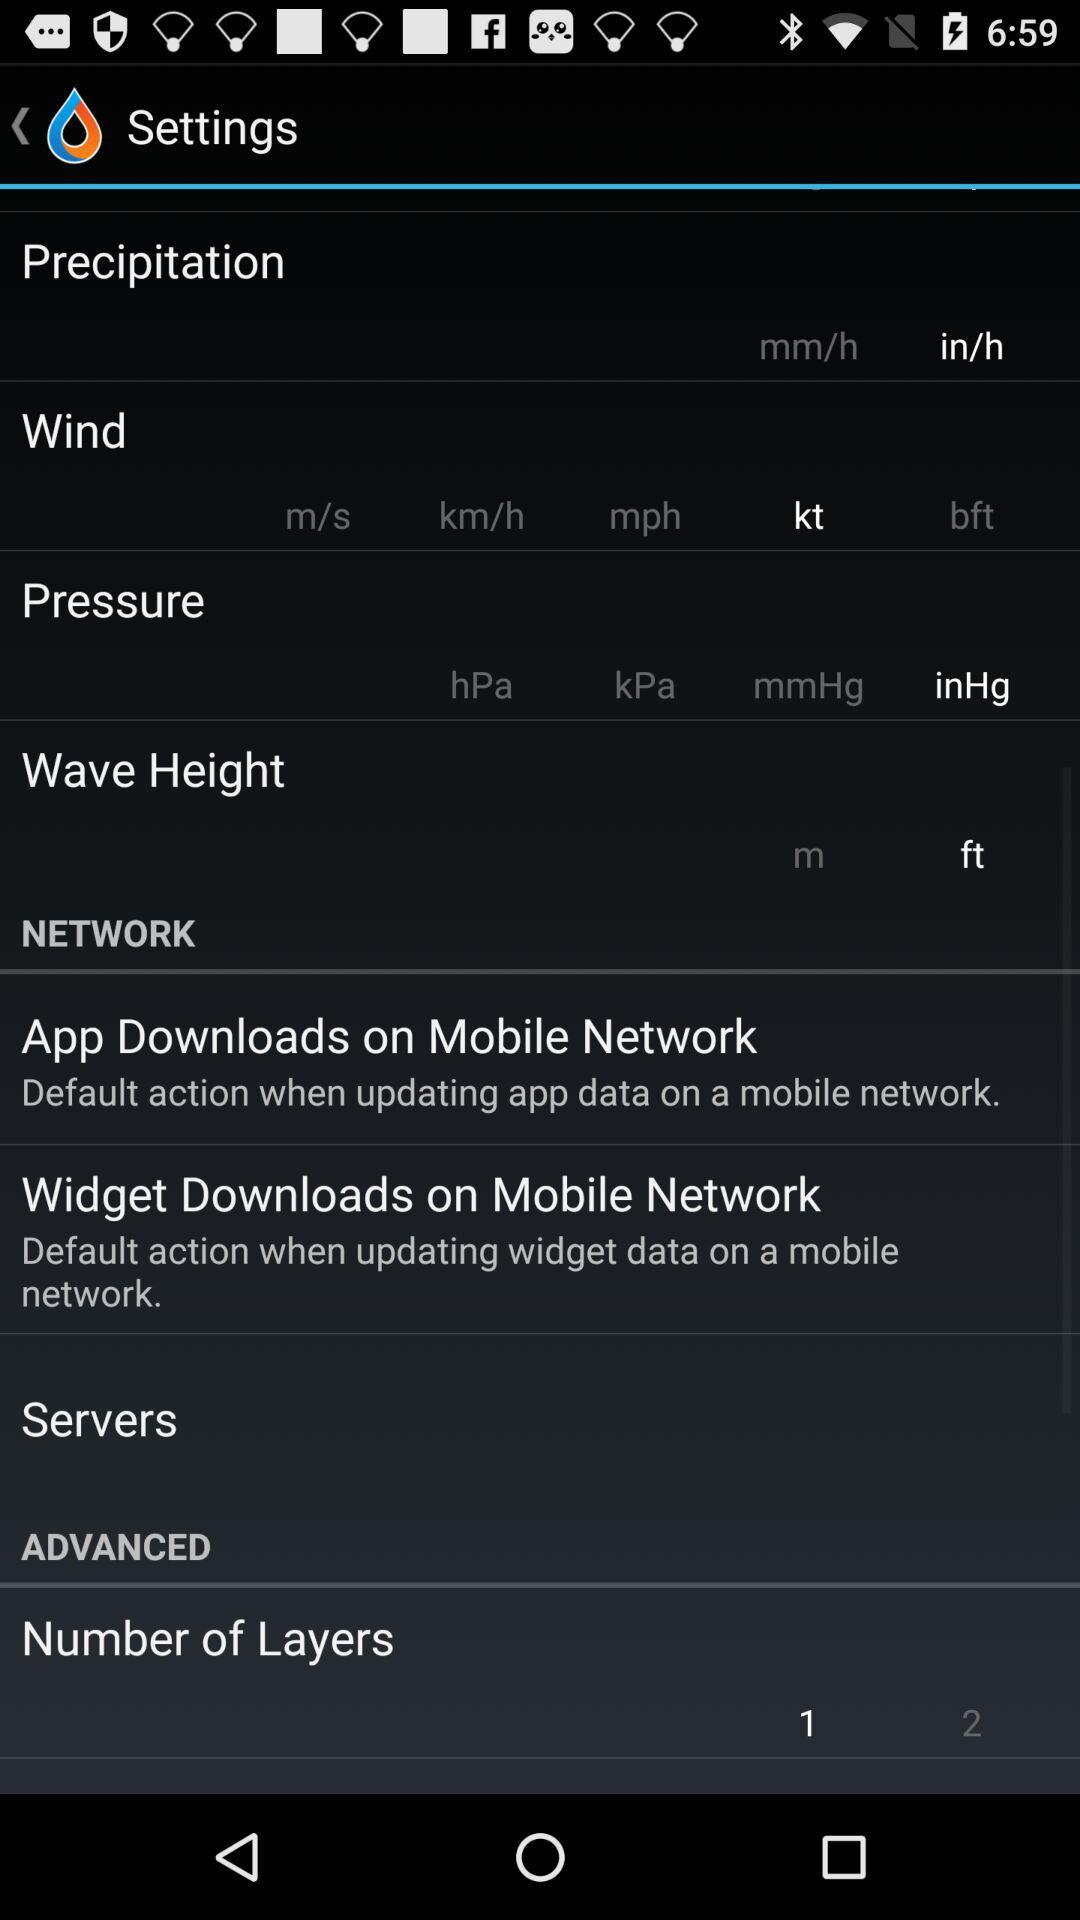What is the precipitation unit? The precipitation unit is "in/h". 